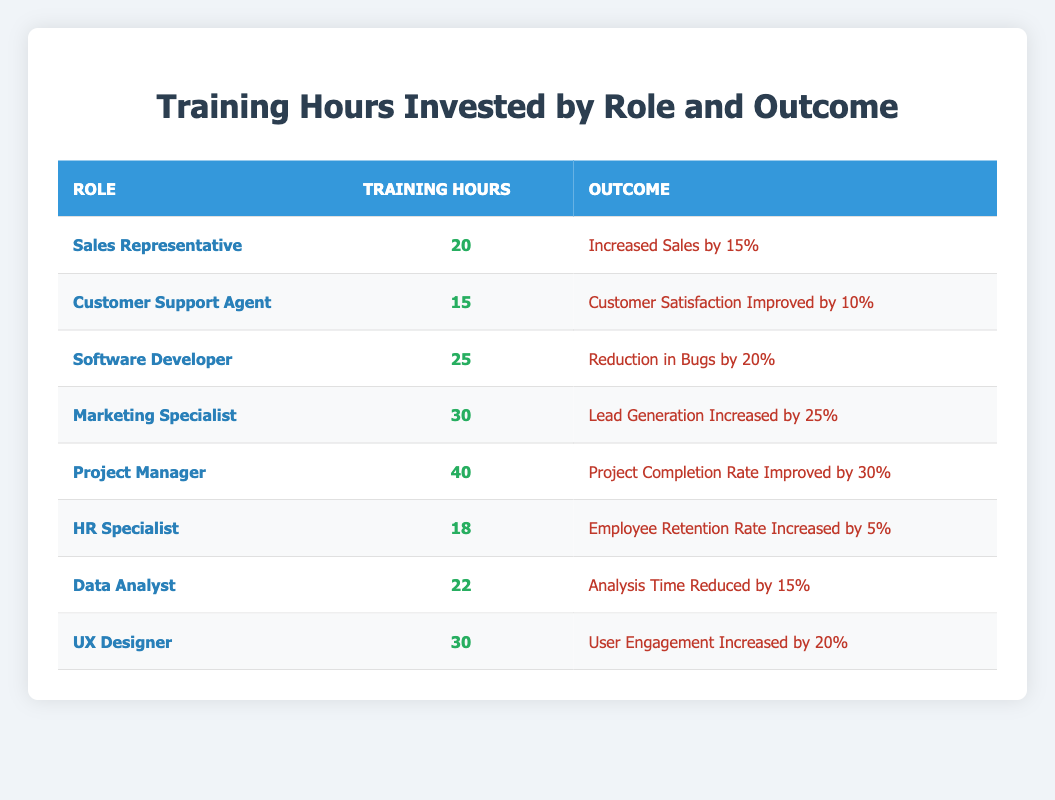What is the training hour total invested by UX Designer? The table lists the training hours for UX Designer specifically under the "Training Hours" column, which shows 30 hours.
Answer: 30 Which role invested the most training hours? By examining the "Training Hours" column, Project Manager has 40 hours, which is higher than any other role listed.
Answer: Project Manager What is the average training hours invested across all roles? To find the average, we sum up all training hours: 20 + 15 + 25 + 30 + 40 + 18 + 22 + 30 = 200. There are 8 roles total, so the average is 200/8 = 25 hours.
Answer: 25 Did the Customer Support Agent invest more than 15 training hours? Based on the table, Customer Support Agent invested exactly 15 training hours, which means it did not exceed.
Answer: No Which outcome is associated with the highest training hours? The highest training hours are 40, associated with the Project Manager, leading to "Project Completion Rate Improved by 30%."
Answer: Project Completion Rate Improved by 30% Is the outcome of "Increased Sales by 15%" associated with the least or the greatest training hours? The "Increased Sales by 15%" outcome is linked to the Sales Representative, who invested 20 training hours, which is not the least (which is 15 hours for Customer Support Agent) but is less than average overall.
Answer: Least How many training hours did software-related roles invest in total? The software-related roles are Software Developer (25 hours) and Data Analyst (22 hours). Adding them gives 25 + 22 = 47 hours in total.
Answer: 47 Do HR Specialists have a higher outcome impact compared to Data Analysts? HR Specialists have an outcome of "Employee Retention Rate Increased by 5%" while Data Analysts have "Analysis Time Reduced by 15%." Since both outcomes are qualitative, they cannot be directly compared and are subjective in their impact. Hence more data would be needed.
Answer: No 